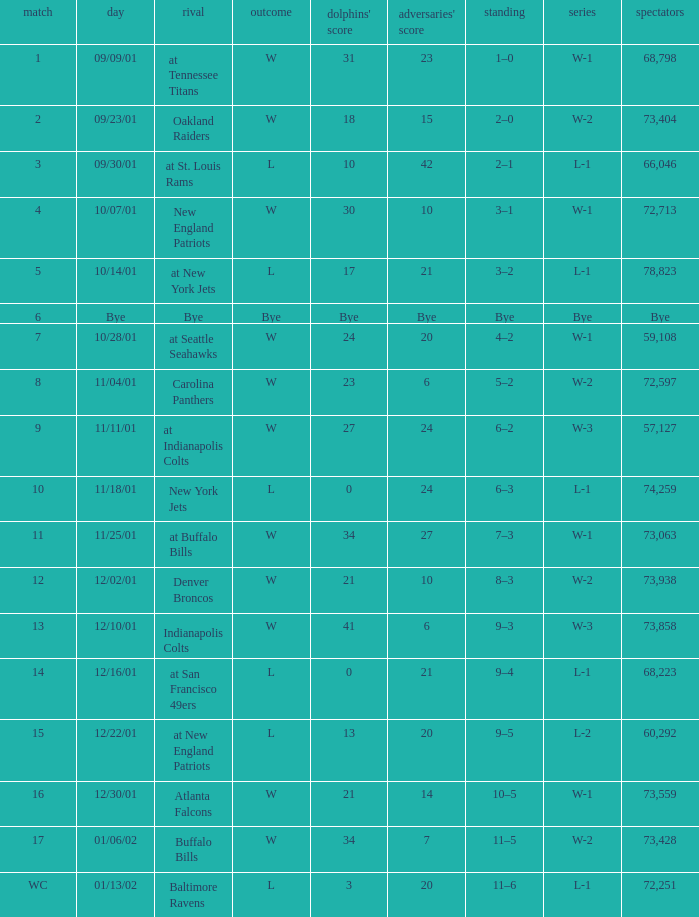What is the streak for game 2? W-2. 